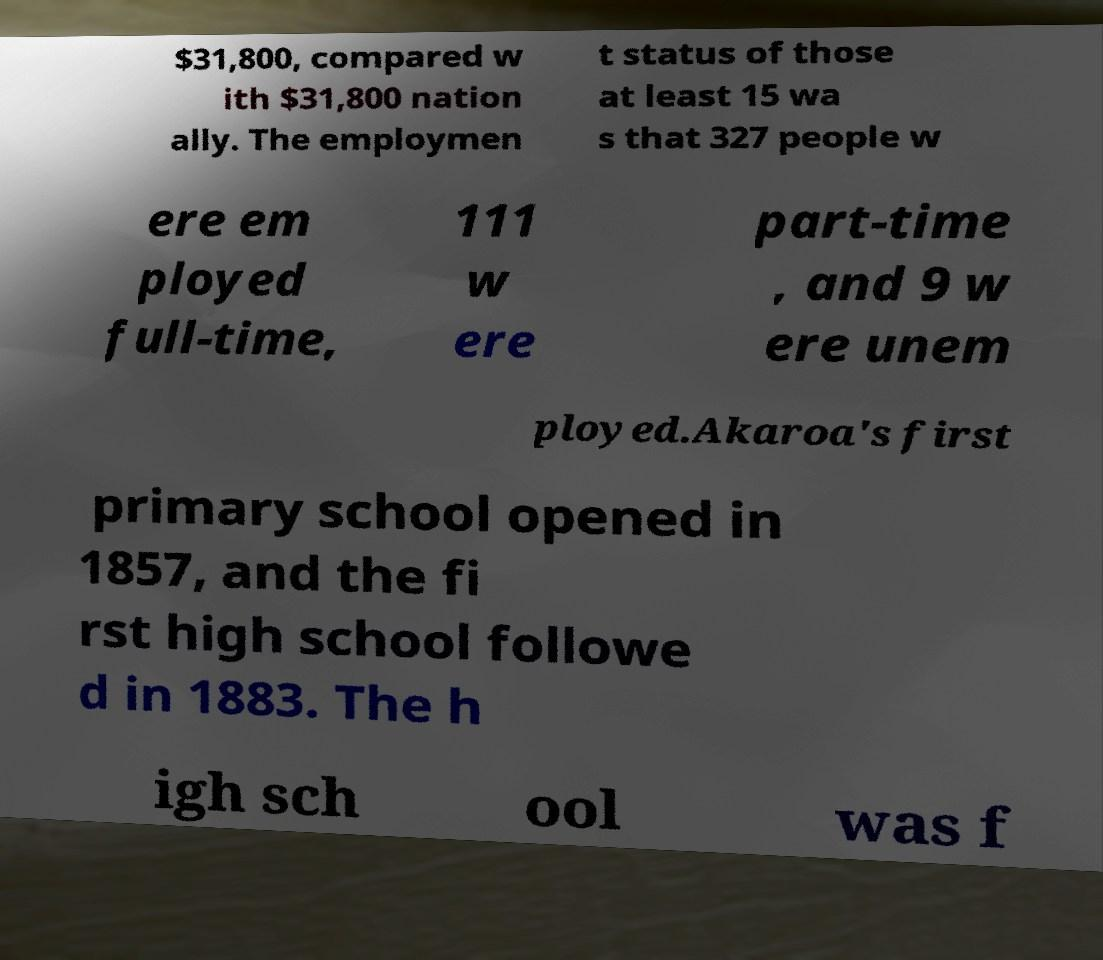Can you accurately transcribe the text from the provided image for me? $31,800, compared w ith $31,800 nation ally. The employmen t status of those at least 15 wa s that 327 people w ere em ployed full-time, 111 w ere part-time , and 9 w ere unem ployed.Akaroa's first primary school opened in 1857, and the fi rst high school followe d in 1883. The h igh sch ool was f 